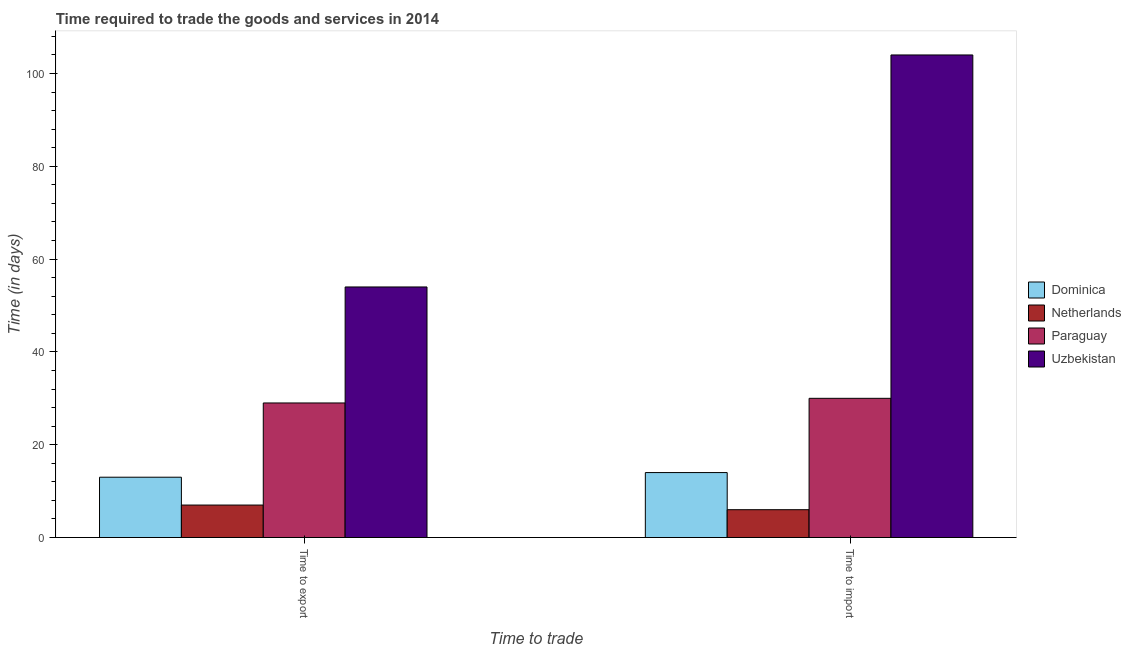How many groups of bars are there?
Your answer should be compact. 2. Are the number of bars per tick equal to the number of legend labels?
Your answer should be compact. Yes. Are the number of bars on each tick of the X-axis equal?
Give a very brief answer. Yes. How many bars are there on the 2nd tick from the right?
Provide a succinct answer. 4. What is the label of the 2nd group of bars from the left?
Your answer should be very brief. Time to import. What is the time to export in Paraguay?
Make the answer very short. 29. Across all countries, what is the maximum time to export?
Make the answer very short. 54. In which country was the time to import maximum?
Your response must be concise. Uzbekistan. In which country was the time to import minimum?
Make the answer very short. Netherlands. What is the total time to import in the graph?
Keep it short and to the point. 154. What is the difference between the time to import in Uzbekistan and that in Netherlands?
Offer a very short reply. 98. What is the difference between the time to export in Netherlands and the time to import in Paraguay?
Your response must be concise. -23. What is the average time to export per country?
Offer a terse response. 25.75. What is the difference between the time to export and time to import in Paraguay?
Offer a terse response. -1. What is the ratio of the time to import in Dominica to that in Paraguay?
Give a very brief answer. 0.47. Is the time to export in Uzbekistan less than that in Paraguay?
Offer a very short reply. No. What does the 2nd bar from the left in Time to import represents?
Your response must be concise. Netherlands. How many bars are there?
Give a very brief answer. 8. How many countries are there in the graph?
Give a very brief answer. 4. Are the values on the major ticks of Y-axis written in scientific E-notation?
Ensure brevity in your answer.  No. Does the graph contain any zero values?
Your answer should be compact. No. Where does the legend appear in the graph?
Provide a succinct answer. Center right. What is the title of the graph?
Make the answer very short. Time required to trade the goods and services in 2014. What is the label or title of the X-axis?
Offer a terse response. Time to trade. What is the label or title of the Y-axis?
Your answer should be very brief. Time (in days). What is the Time (in days) in Dominica in Time to export?
Provide a succinct answer. 13. What is the Time (in days) in Netherlands in Time to export?
Offer a terse response. 7. What is the Time (in days) of Paraguay in Time to export?
Provide a short and direct response. 29. What is the Time (in days) in Dominica in Time to import?
Your answer should be compact. 14. What is the Time (in days) of Paraguay in Time to import?
Give a very brief answer. 30. What is the Time (in days) in Uzbekistan in Time to import?
Provide a succinct answer. 104. Across all Time to trade, what is the maximum Time (in days) in Paraguay?
Offer a terse response. 30. Across all Time to trade, what is the maximum Time (in days) in Uzbekistan?
Provide a succinct answer. 104. Across all Time to trade, what is the minimum Time (in days) of Dominica?
Ensure brevity in your answer.  13. Across all Time to trade, what is the minimum Time (in days) in Netherlands?
Offer a terse response. 6. Across all Time to trade, what is the minimum Time (in days) of Paraguay?
Offer a very short reply. 29. What is the total Time (in days) of Paraguay in the graph?
Your answer should be compact. 59. What is the total Time (in days) in Uzbekistan in the graph?
Offer a terse response. 158. What is the difference between the Time (in days) of Dominica in Time to export and the Time (in days) of Netherlands in Time to import?
Make the answer very short. 7. What is the difference between the Time (in days) in Dominica in Time to export and the Time (in days) in Paraguay in Time to import?
Your answer should be very brief. -17. What is the difference between the Time (in days) of Dominica in Time to export and the Time (in days) of Uzbekistan in Time to import?
Your response must be concise. -91. What is the difference between the Time (in days) of Netherlands in Time to export and the Time (in days) of Paraguay in Time to import?
Make the answer very short. -23. What is the difference between the Time (in days) of Netherlands in Time to export and the Time (in days) of Uzbekistan in Time to import?
Your answer should be compact. -97. What is the difference between the Time (in days) in Paraguay in Time to export and the Time (in days) in Uzbekistan in Time to import?
Keep it short and to the point. -75. What is the average Time (in days) in Netherlands per Time to trade?
Make the answer very short. 6.5. What is the average Time (in days) of Paraguay per Time to trade?
Make the answer very short. 29.5. What is the average Time (in days) of Uzbekistan per Time to trade?
Offer a terse response. 79. What is the difference between the Time (in days) in Dominica and Time (in days) in Uzbekistan in Time to export?
Give a very brief answer. -41. What is the difference between the Time (in days) in Netherlands and Time (in days) in Uzbekistan in Time to export?
Offer a very short reply. -47. What is the difference between the Time (in days) of Dominica and Time (in days) of Netherlands in Time to import?
Your answer should be very brief. 8. What is the difference between the Time (in days) in Dominica and Time (in days) in Paraguay in Time to import?
Provide a succinct answer. -16. What is the difference between the Time (in days) of Dominica and Time (in days) of Uzbekistan in Time to import?
Ensure brevity in your answer.  -90. What is the difference between the Time (in days) of Netherlands and Time (in days) of Uzbekistan in Time to import?
Offer a very short reply. -98. What is the difference between the Time (in days) of Paraguay and Time (in days) of Uzbekistan in Time to import?
Give a very brief answer. -74. What is the ratio of the Time (in days) in Netherlands in Time to export to that in Time to import?
Provide a short and direct response. 1.17. What is the ratio of the Time (in days) of Paraguay in Time to export to that in Time to import?
Offer a terse response. 0.97. What is the ratio of the Time (in days) of Uzbekistan in Time to export to that in Time to import?
Your answer should be very brief. 0.52. What is the difference between the highest and the lowest Time (in days) in Uzbekistan?
Offer a terse response. 50. 